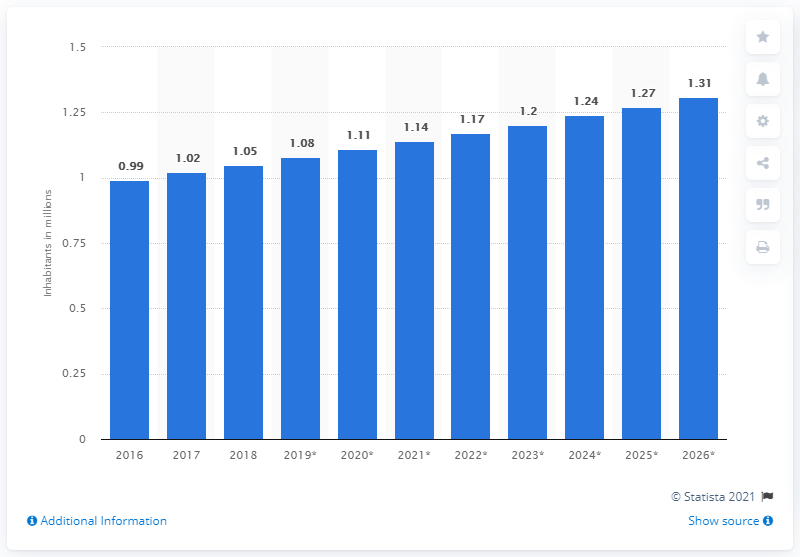List a handful of essential elements in this visual. In 2018, the population of Djibouti was approximately 1.05 million. 